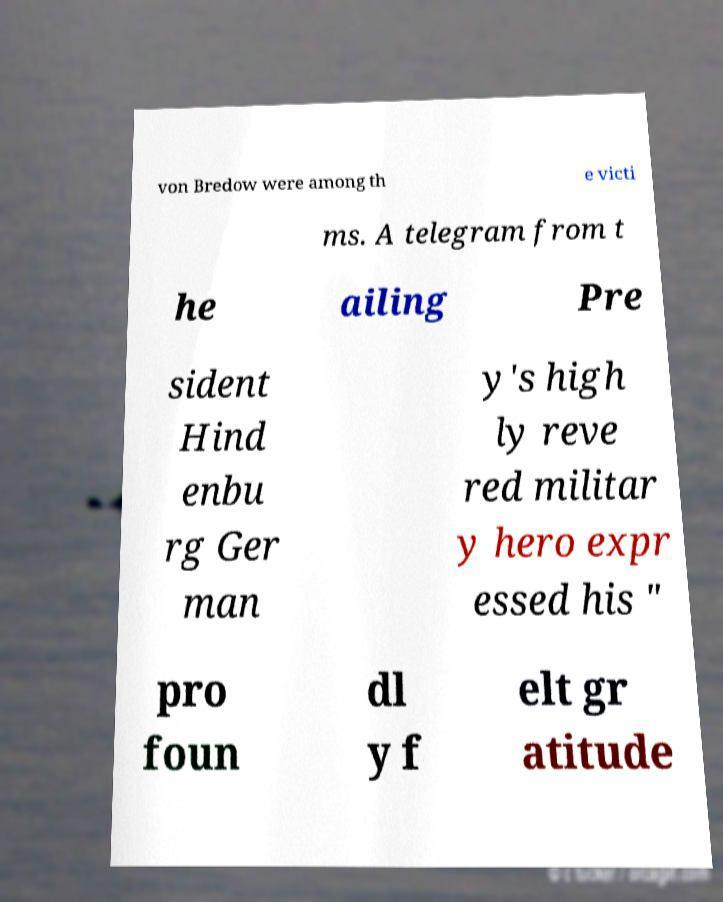Could you assist in decoding the text presented in this image and type it out clearly? von Bredow were among th e victi ms. A telegram from t he ailing Pre sident Hind enbu rg Ger man y's high ly reve red militar y hero expr essed his " pro foun dl y f elt gr atitude 